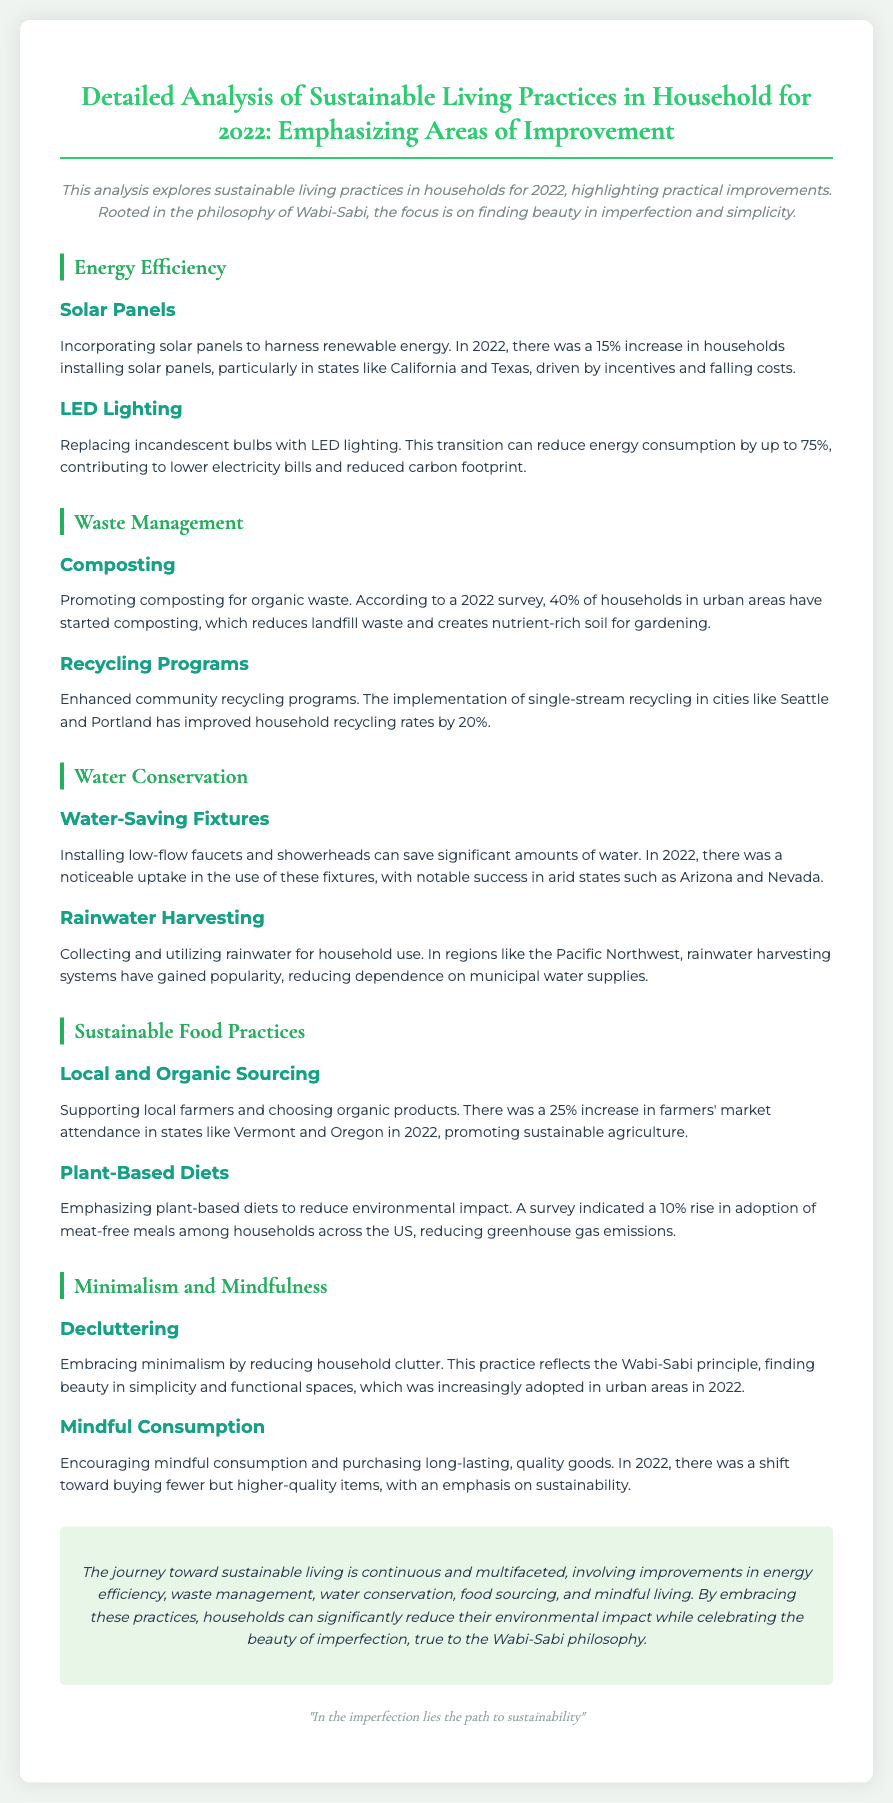What was the increase in households installing solar panels in 2022? The document states there was a 15% increase in households installing solar panels in 2022.
Answer: 15% What percentage of urban households started composting in 2022? According to the document, 40% of households in urban areas started composting in 2022.
Answer: 40% Which two states showed notable success in the installation of water-saving fixtures? The document mentions Arizona and Nevada as states with noticeable uptake in water-saving fixtures.
Answer: Arizona and Nevada What was the percentage increase in farmers' market attendance in 2022? The document reports a 25% increase in farmers' market attendance in 2022.
Answer: 25% What principle reflects the practice of decluttering in sustainable living? The document indicates that the practice of decluttering reflects the Wabi-Sabi principle.
Answer: Wabi-Sabi How much can LED lighting reduce energy consumption by? The document states LED lighting can reduce energy consumption by up to 75%.
Answer: 75% What is the focus of the analysis as stated in the introduction? The introduction emphasizes finding beauty in imperfection and simplicity.
Answer: Beauty in imperfection and simplicity Which two cities improved household recycling rates by 20%? The document states that Seattle and Portland improved household recycling rates by 20%.
Answer: Seattle and Portland 